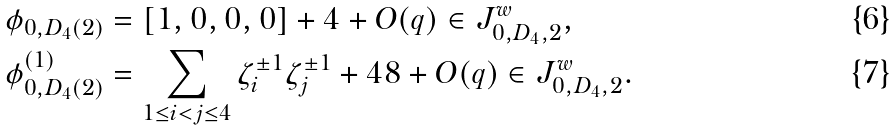Convert formula to latex. <formula><loc_0><loc_0><loc_500><loc_500>\phi _ { 0 , D _ { 4 } ( 2 ) } & = [ 1 , 0 , 0 , 0 ] + 4 + O ( q ) \in J _ { 0 , D _ { 4 } , 2 } ^ { w } , \\ \phi ^ { ( 1 ) } _ { 0 , D _ { 4 } ( 2 ) } & = \sum _ { 1 \leq i < j \leq 4 } \zeta _ { i } ^ { \pm 1 } \zeta _ { j } ^ { \pm 1 } + 4 8 + O ( q ) \in J _ { 0 , D _ { 4 } , 2 } ^ { w } .</formula> 